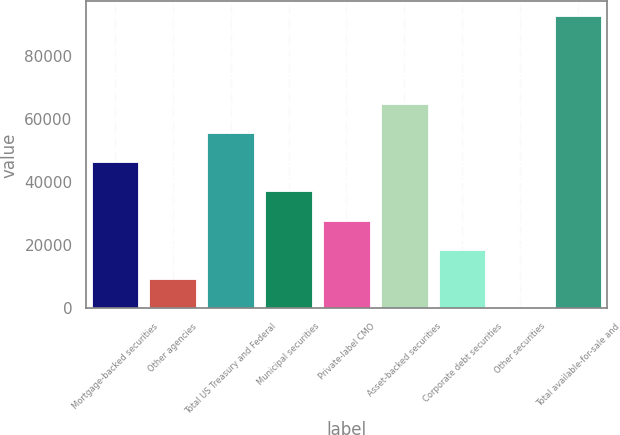Convert chart. <chart><loc_0><loc_0><loc_500><loc_500><bar_chart><fcel>Mortgage-backed securities<fcel>Other agencies<fcel>Total US Treasury and Federal<fcel>Municipal securities<fcel>Private-label CMO<fcel>Asset-backed securities<fcel>Corporate debt securities<fcel>Other securities<fcel>Total available-for-sale and<nl><fcel>46427<fcel>9352.6<fcel>55695.6<fcel>37158.4<fcel>27889.8<fcel>64964.2<fcel>18621.2<fcel>84<fcel>92770<nl></chart> 